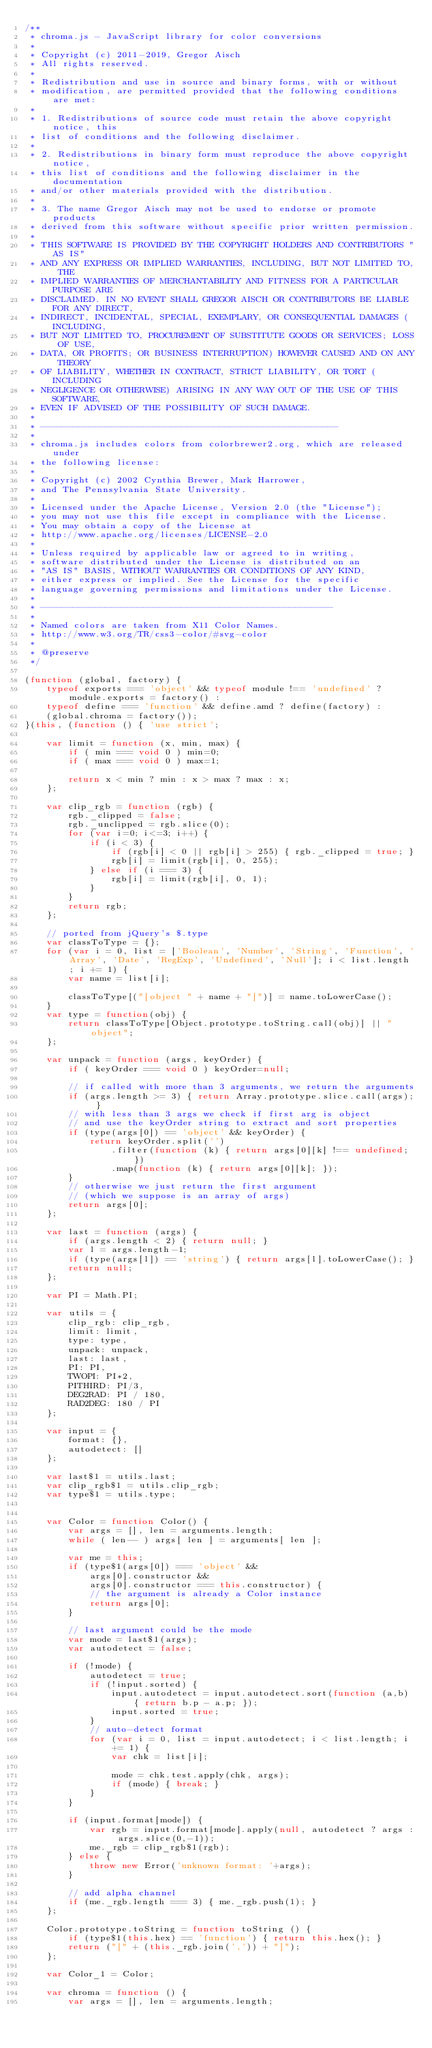Convert code to text. <code><loc_0><loc_0><loc_500><loc_500><_JavaScript_>/**
 * chroma.js - JavaScript library for color conversions
 *
 * Copyright (c) 2011-2019, Gregor Aisch
 * All rights reserved.
 *
 * Redistribution and use in source and binary forms, with or without
 * modification, are permitted provided that the following conditions are met:
 *
 * 1. Redistributions of source code must retain the above copyright notice, this
 * list of conditions and the following disclaimer.
 *
 * 2. Redistributions in binary form must reproduce the above copyright notice,
 * this list of conditions and the following disclaimer in the documentation
 * and/or other materials provided with the distribution.
 *
 * 3. The name Gregor Aisch may not be used to endorse or promote products
 * derived from this software without specific prior written permission.
 *
 * THIS SOFTWARE IS PROVIDED BY THE COPYRIGHT HOLDERS AND CONTRIBUTORS "AS IS"
 * AND ANY EXPRESS OR IMPLIED WARRANTIES, INCLUDING, BUT NOT LIMITED TO, THE
 * IMPLIED WARRANTIES OF MERCHANTABILITY AND FITNESS FOR A PARTICULAR PURPOSE ARE
 * DISCLAIMED. IN NO EVENT SHALL GREGOR AISCH OR CONTRIBUTORS BE LIABLE FOR ANY DIRECT,
 * INDIRECT, INCIDENTAL, SPECIAL, EXEMPLARY, OR CONSEQUENTIAL DAMAGES (INCLUDING,
 * BUT NOT LIMITED TO, PROCUREMENT OF SUBSTITUTE GOODS OR SERVICES; LOSS OF USE,
 * DATA, OR PROFITS; OR BUSINESS INTERRUPTION) HOWEVER CAUSED AND ON ANY THEORY
 * OF LIABILITY, WHETHER IN CONTRACT, STRICT LIABILITY, OR TORT (INCLUDING
 * NEGLIGENCE OR OTHERWISE) ARISING IN ANY WAY OUT OF THE USE OF THIS SOFTWARE,
 * EVEN IF ADVISED OF THE POSSIBILITY OF SUCH DAMAGE.
 *
 * -------------------------------------------------------
 *
 * chroma.js includes colors from colorbrewer2.org, which are released under
 * the following license:
 *
 * Copyright (c) 2002 Cynthia Brewer, Mark Harrower,
 * and The Pennsylvania State University.
 *
 * Licensed under the Apache License, Version 2.0 (the "License");
 * you may not use this file except in compliance with the License.
 * You may obtain a copy of the License at
 * http://www.apache.org/licenses/LICENSE-2.0
 *
 * Unless required by applicable law or agreed to in writing,
 * software distributed under the License is distributed on an
 * "AS IS" BASIS, WITHOUT WARRANTIES OR CONDITIONS OF ANY KIND,
 * either express or implied. See the License for the specific
 * language governing permissions and limitations under the License.
 *
 * ------------------------------------------------------
 *
 * Named colors are taken from X11 Color Names.
 * http://www.w3.org/TR/css3-color/#svg-color
 *
 * @preserve
 */

(function (global, factory) {
    typeof exports === 'object' && typeof module !== 'undefined' ? module.exports = factory() :
    typeof define === 'function' && define.amd ? define(factory) :
    (global.chroma = factory());
}(this, (function () { 'use strict';

    var limit = function (x, min, max) {
        if ( min === void 0 ) min=0;
        if ( max === void 0 ) max=1;

        return x < min ? min : x > max ? max : x;
    };

    var clip_rgb = function (rgb) {
        rgb._clipped = false;
        rgb._unclipped = rgb.slice(0);
        for (var i=0; i<=3; i++) {
            if (i < 3) {
                if (rgb[i] < 0 || rgb[i] > 255) { rgb._clipped = true; }
                rgb[i] = limit(rgb[i], 0, 255);
            } else if (i === 3) {
                rgb[i] = limit(rgb[i], 0, 1);
            }
        }
        return rgb;
    };

    // ported from jQuery's $.type
    var classToType = {};
    for (var i = 0, list = ['Boolean', 'Number', 'String', 'Function', 'Array', 'Date', 'RegExp', 'Undefined', 'Null']; i < list.length; i += 1) {
        var name = list[i];

        classToType[("[object " + name + "]")] = name.toLowerCase();
    }
    var type = function(obj) {
        return classToType[Object.prototype.toString.call(obj)] || "object";
    };

    var unpack = function (args, keyOrder) {
        if ( keyOrder === void 0 ) keyOrder=null;

    	// if called with more than 3 arguments, we return the arguments
        if (args.length >= 3) { return Array.prototype.slice.call(args); }
        // with less than 3 args we check if first arg is object
        // and use the keyOrder string to extract and sort properties
    	if (type(args[0]) == 'object' && keyOrder) {
    		return keyOrder.split('')
    			.filter(function (k) { return args[0][k] !== undefined; })
    			.map(function (k) { return args[0][k]; });
    	}
    	// otherwise we just return the first argument
    	// (which we suppose is an array of args)
        return args[0];
    };

    var last = function (args) {
        if (args.length < 2) { return null; }
        var l = args.length-1;
        if (type(args[l]) == 'string') { return args[l].toLowerCase(); }
        return null;
    };

    var PI = Math.PI;

    var utils = {
    	clip_rgb: clip_rgb,
    	limit: limit,
    	type: type,
    	unpack: unpack,
    	last: last,
    	PI: PI,
    	TWOPI: PI*2,
    	PITHIRD: PI/3,
    	DEG2RAD: PI / 180,
    	RAD2DEG: 180 / PI
    };

    var input = {
    	format: {},
    	autodetect: []
    };

    var last$1 = utils.last;
    var clip_rgb$1 = utils.clip_rgb;
    var type$1 = utils.type;


    var Color = function Color() {
        var args = [], len = arguments.length;
        while ( len-- ) args[ len ] = arguments[ len ];

        var me = this;
        if (type$1(args[0]) === 'object' &&
            args[0].constructor &&
            args[0].constructor === this.constructor) {
            // the argument is already a Color instance
            return args[0];
        }

        // last argument could be the mode
        var mode = last$1(args);
        var autodetect = false;

        if (!mode) {
            autodetect = true;
            if (!input.sorted) {
                input.autodetect = input.autodetect.sort(function (a,b) { return b.p - a.p; });
                input.sorted = true;
            }
            // auto-detect format
            for (var i = 0, list = input.autodetect; i < list.length; i += 1) {
                var chk = list[i];

                mode = chk.test.apply(chk, args);
                if (mode) { break; }
            }
        }

        if (input.format[mode]) {
            var rgb = input.format[mode].apply(null, autodetect ? args : args.slice(0,-1));
            me._rgb = clip_rgb$1(rgb);
        } else {
            throw new Error('unknown format: '+args);
        }

        // add alpha channel
        if (me._rgb.length === 3) { me._rgb.push(1); }
    };

    Color.prototype.toString = function toString () {
        if (type$1(this.hex) == 'function') { return this.hex(); }
        return ("[" + (this._rgb.join(',')) + "]");
    };

    var Color_1 = Color;

    var chroma = function () {
    	var args = [], len = arguments.length;</code> 